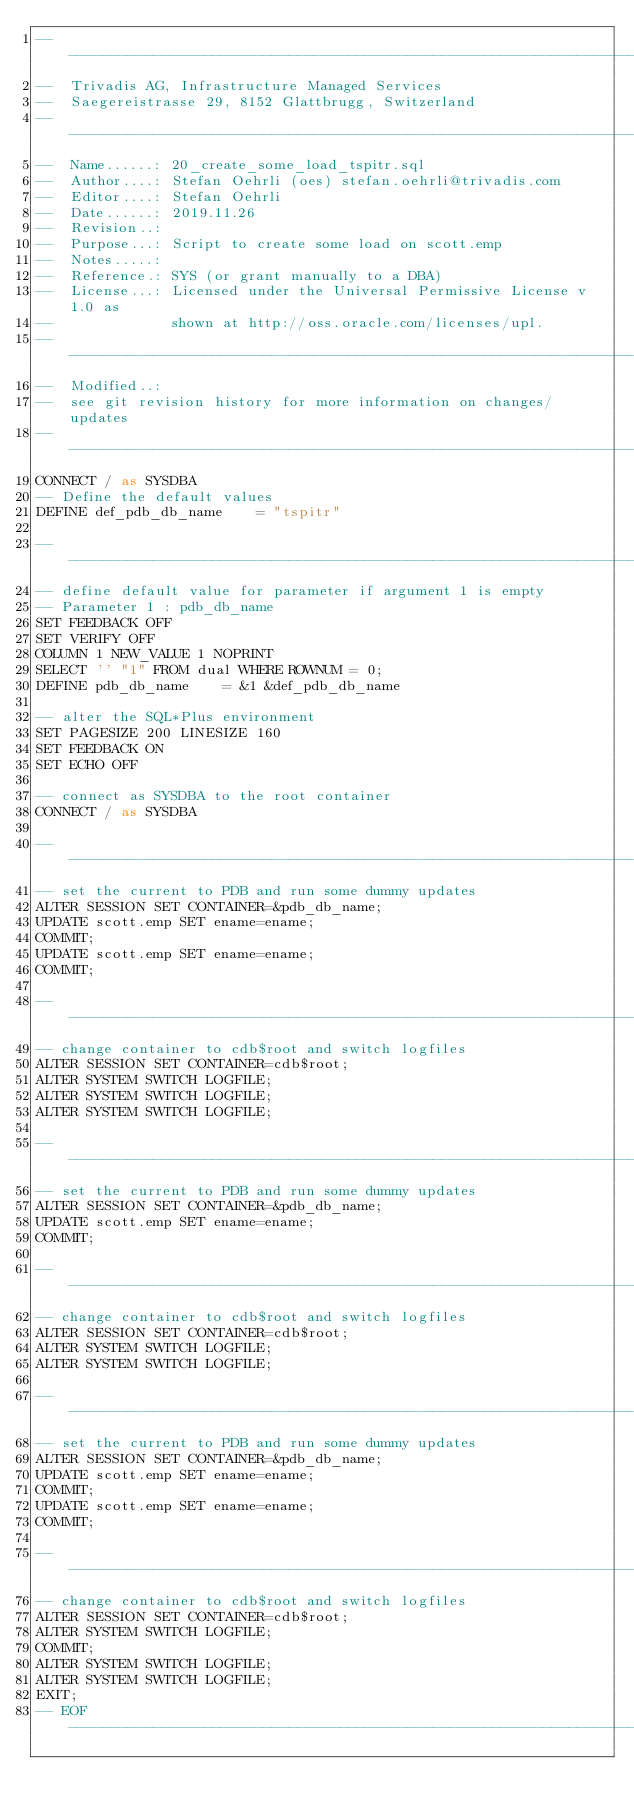Convert code to text. <code><loc_0><loc_0><loc_500><loc_500><_SQL_>----------------------------------------------------------------------------
--  Trivadis AG, Infrastructure Managed Services
--  Saegereistrasse 29, 8152 Glattbrugg, Switzerland
----------------------------------------------------------------------------
--  Name......: 20_create_some_load_tspitr.sql
--  Author....: Stefan Oehrli (oes) stefan.oehrli@trivadis.com
--  Editor....: Stefan Oehrli
--  Date......: 2019.11.26
--  Revision..:  
--  Purpose...: Script to create some load on scott.emp
--  Notes.....:  
--  Reference.: SYS (or grant manually to a DBA)
--  License...: Licensed under the Universal Permissive License v 1.0 as 
--              shown at http://oss.oracle.com/licenses/upl.
----------------------------------------------------------------------------
--  Modified..:
--  see git revision history for more information on changes/updates
----------------------------------------------------------------------------
CONNECT / as SYSDBA
-- Define the default values 
DEFINE def_pdb_db_name    = "tspitr"

---------------------------------------------------------------------------
-- define default value for parameter if argument 1 is empty
-- Parameter 1 : pdb_db_name
SET FEEDBACK OFF
SET VERIFY OFF
COLUMN 1 NEW_VALUE 1 NOPRINT
SELECT '' "1" FROM dual WHERE ROWNUM = 0;
DEFINE pdb_db_name    = &1 &def_pdb_db_name

-- alter the SQL*Plus environment
SET PAGESIZE 200 LINESIZE 160
SET FEEDBACK ON
SET ECHO OFF

-- connect as SYSDBA to the root container
CONNECT / as SYSDBA

---------------------------------------------------------------------------
-- set the current to PDB and run some dummy updates
ALTER SESSION SET CONTAINER=&pdb_db_name;
UPDATE scott.emp SET ename=ename;
COMMIT;
UPDATE scott.emp SET ename=ename;
COMMIT;

---------------------------------------------------------------------------
-- change container to cdb$root and switch logfiles
ALTER SESSION SET CONTAINER=cdb$root;
ALTER SYSTEM SWITCH LOGFILE;
ALTER SYSTEM SWITCH LOGFILE;
ALTER SYSTEM SWITCH LOGFILE;

---------------------------------------------------------------------------
-- set the current to PDB and run some dummy updates
ALTER SESSION SET CONTAINER=&pdb_db_name;
UPDATE scott.emp SET ename=ename;
COMMIT;

---------------------------------------------------------------------------
-- change container to cdb$root and switch logfiles
ALTER SESSION SET CONTAINER=cdb$root;
ALTER SYSTEM SWITCH LOGFILE;
ALTER SYSTEM SWITCH LOGFILE;

---------------------------------------------------------------------------
-- set the current to PDB and run some dummy updates
ALTER SESSION SET CONTAINER=&pdb_db_name;
UPDATE scott.emp SET ename=ename;
COMMIT;
UPDATE scott.emp SET ename=ename;
COMMIT;

---------------------------------------------------------------------------
-- change container to cdb$root and switch logfiles
ALTER SESSION SET CONTAINER=cdb$root;
ALTER SYSTEM SWITCH LOGFILE;
COMMIT;
ALTER SYSTEM SWITCH LOGFILE;
ALTER SYSTEM SWITCH LOGFILE;
EXIT;
-- EOF ---------------------------------------------------------------------</code> 